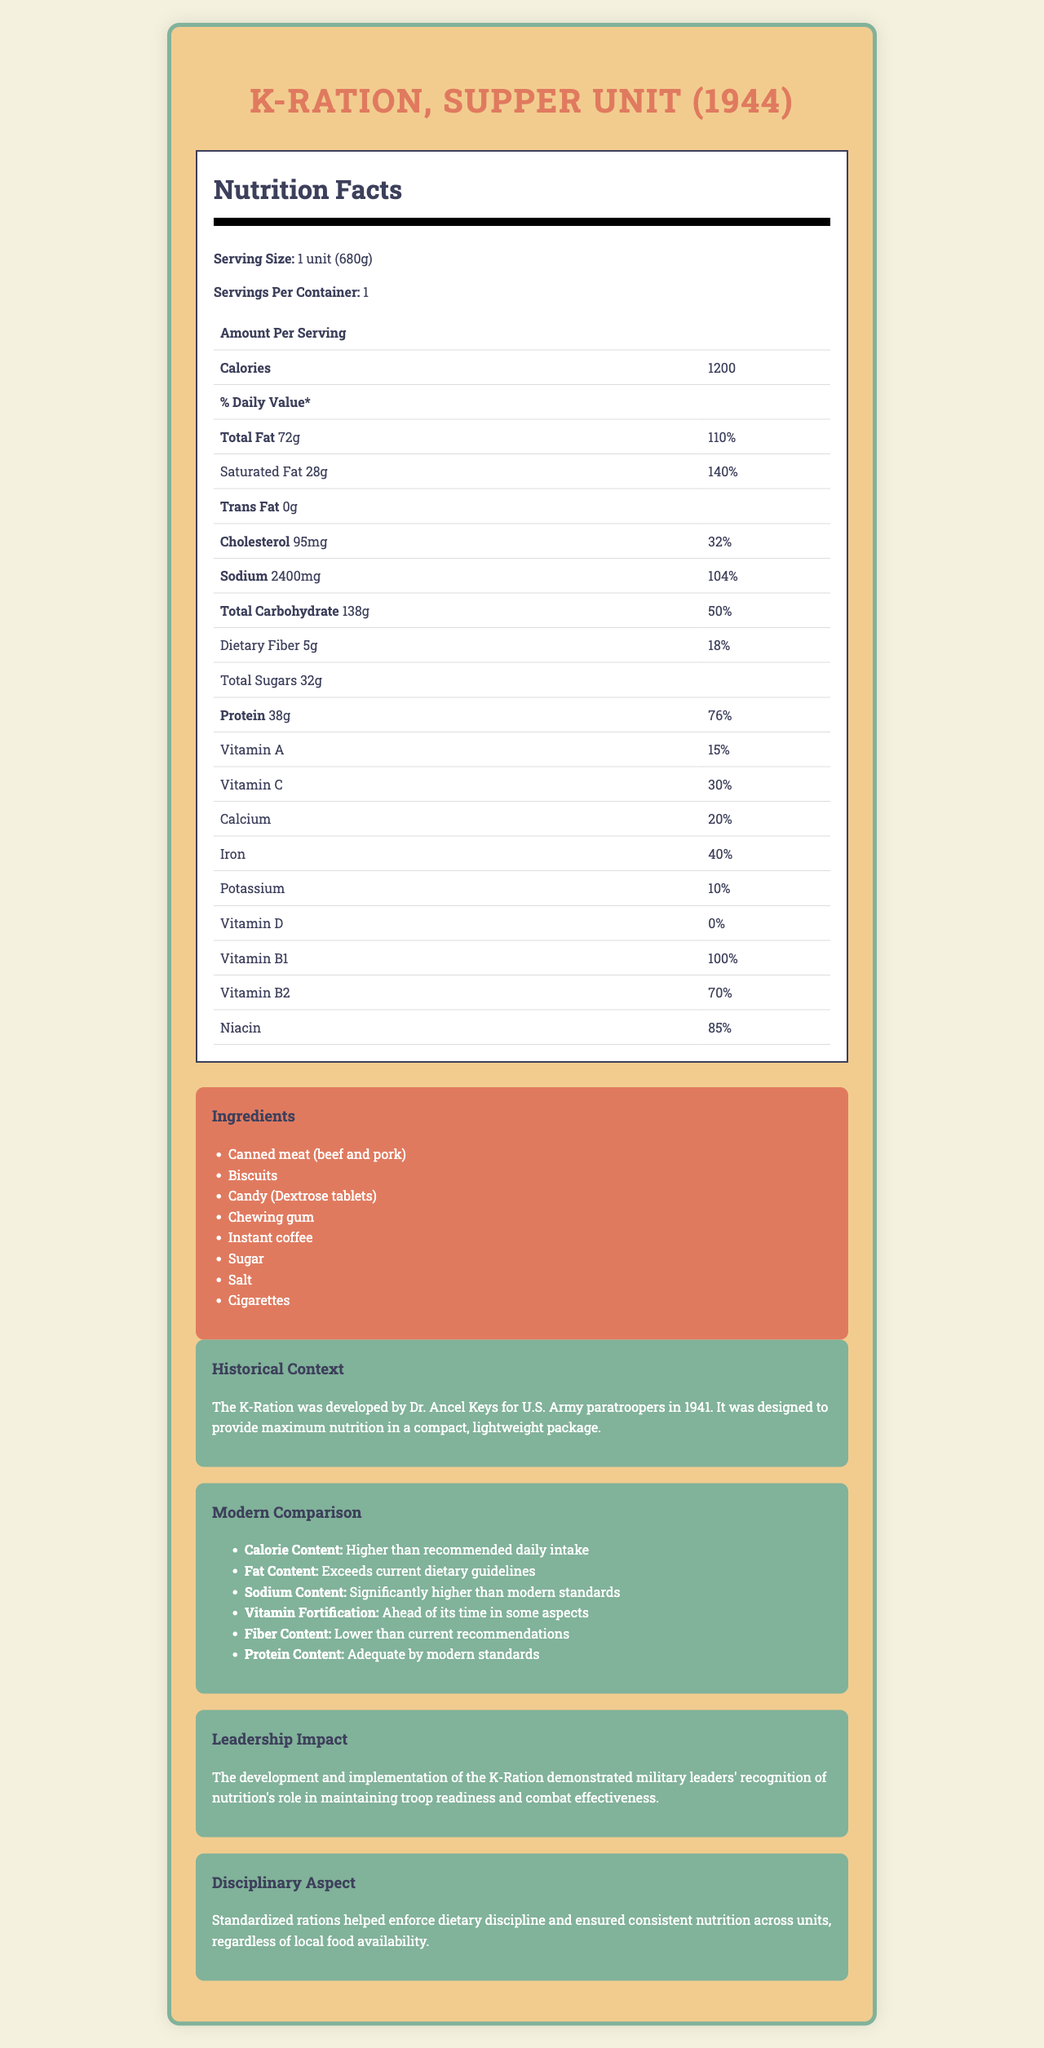Who developed the K-Ration for U.S. Army paratroopers? The historical context section states that the K-Ration was developed by Dr. Ancel Keys for U.S. Army paratroopers in 1941.
Answer: Dr. Ancel Keys What is the serving size of the K-Ration, Supper Unit (1944)? The serving size is listed at the top of the nutrition label section.
Answer: 1 unit (680g) How many calories are in one serving of the K-Ration? The nutrition label shows that one serving contains 1200 calories.
Answer: 1200 calories What is the total fat content in the K-Ration, and how does it compare to the daily recommended value? The nutrition label indicates the total fat content as 72g, which is 110% of the daily recommended value.
Answer: 72g, 110% What percentage of the daily recommended sodium intake does the K-Ration provide? The nutrition label shows that the K-Ration provides 104% of the daily recommended sodium intake.
Answer: 104% Which of the following ingredients is NOT listed in the K-Ration? A. Chewing gum B. Chocolate C. Cigarettes The ingredients list includes chewing gum and cigarettes but not chocolate.
Answer: B. Chocolate Which vitamin has the highest percentage of the daily value in the K-Ration? A. Vitamin A B. Vitamin C C. Vitamin B1 D. Iron The nutrition label shows that Vitamin B1 has a daily value of 100%, the highest among listed vitamins.
Answer: C. Vitamin B1 Does the K-Ration meet modern fiber intake recommendations? Yes/No The modern comparison section indicates that the fiber content in the K-Ration is lower than current recommendations.
Answer: No Describe the main idea of the document. The document includes detailed nutritional facts, historical background, and a comparison with modern standards to provide a comprehensive overview of the K-Ration's significance.
Answer: The document provides nutritional information about the K-Ration Supper Unit from 1944, highlighting its contents, historical context, and how it compares to modern nutritional standards. It also examines the impact of military leadership on dietary discipline and nutrition in the context of the K-Ration. What were the recommended calorie and fat intakes during World War II for soldiers? The document does not provide specific information on the recommended calorie and fat intakes for soldiers during World War II.
Answer: Cannot be determined How did the development and implementation of the K-Ration demonstrate military leadership's recognition of nutrition? The leadership impact section explains how the K-Ration exemplified leaders' awareness of the importance of nutrition for military effectiveness and discipline.
Answer: By providing a standardized, compact, and nutritionally balanced meal to maintain troop readiness and combat effectiveness, leaders ensured soldiers were well-fed and healthy regardless of local food availability. 